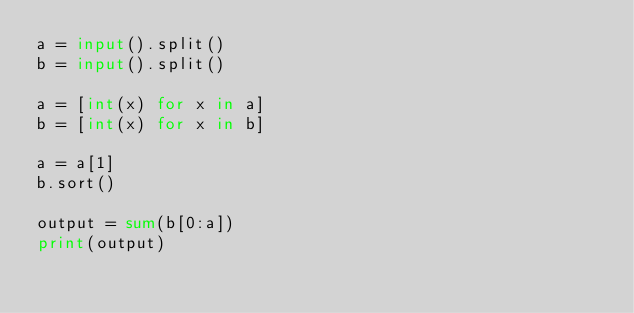<code> <loc_0><loc_0><loc_500><loc_500><_Python_>a = input().split()
b = input().split()

a = [int(x) for x in a]
b = [int(x) for x in b]

a = a[1]
b.sort()

output = sum(b[0:a])
print(output)</code> 